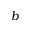Convert formula to latex. <formula><loc_0><loc_0><loc_500><loc_500>b</formula> 